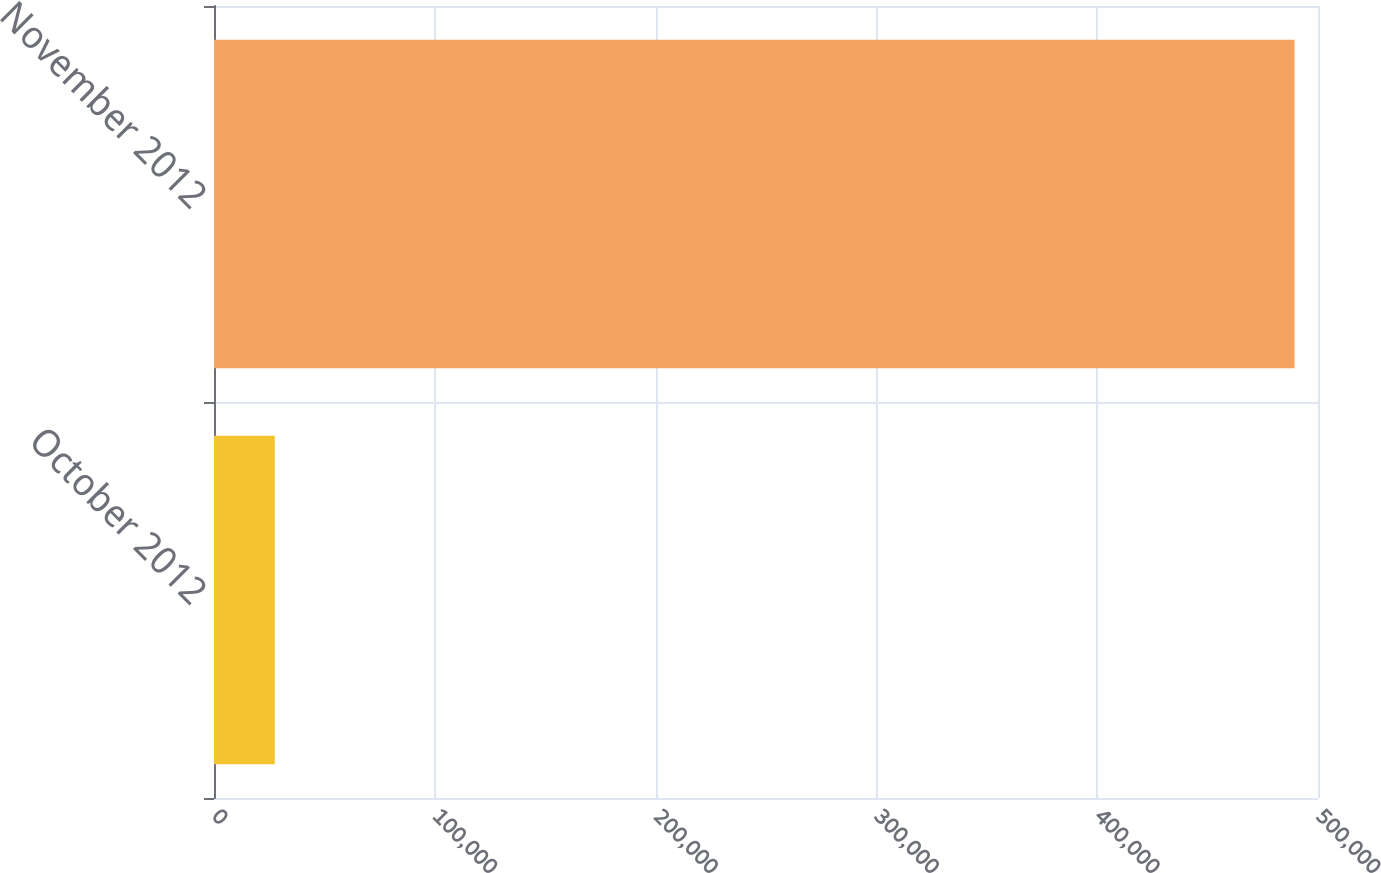<chart> <loc_0><loc_0><loc_500><loc_500><bar_chart><fcel>October 2012<fcel>November 2012<nl><fcel>27524<fcel>489390<nl></chart> 